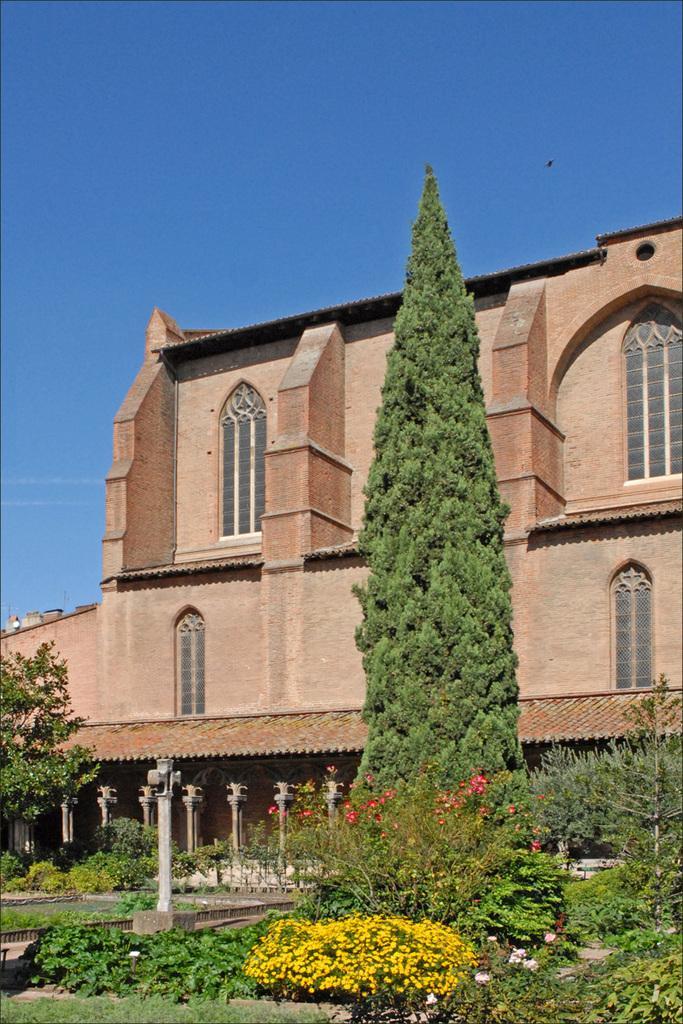How would you summarize this image in a sentence or two? This picture consists of a building , in front of the building there are poles, plants and flowers and trees ,at the top I can see the sky. 